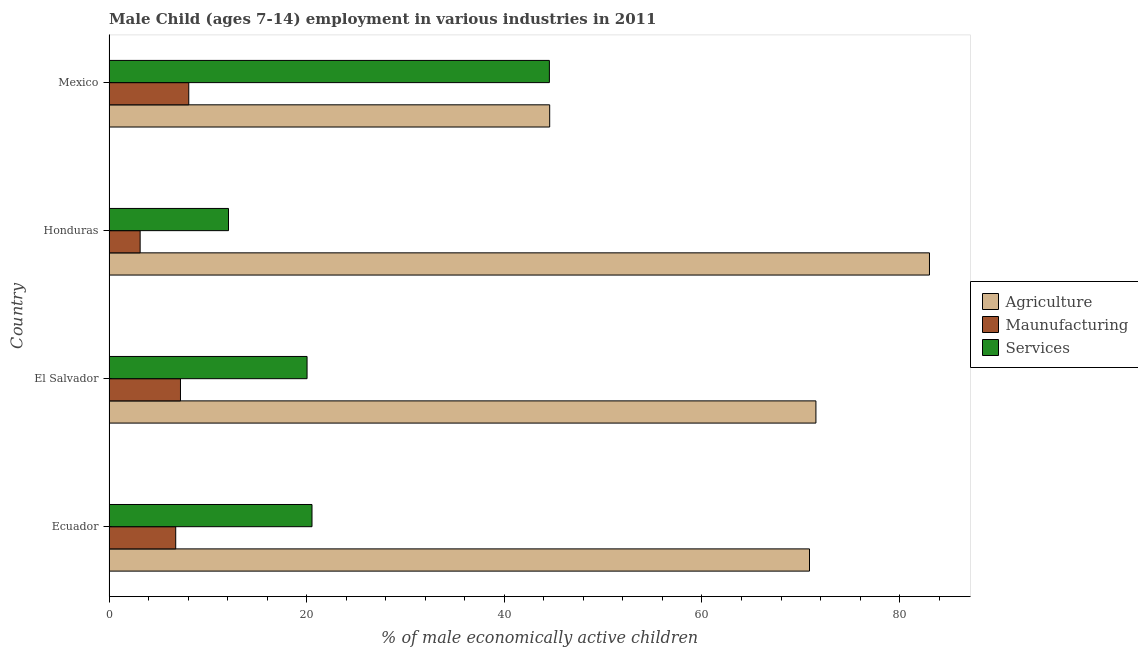How many different coloured bars are there?
Your answer should be very brief. 3. Are the number of bars on each tick of the Y-axis equal?
Provide a succinct answer. Yes. In how many cases, is the number of bars for a given country not equal to the number of legend labels?
Provide a succinct answer. 0. What is the percentage of economically active children in services in Ecuador?
Your answer should be very brief. 20.54. Across all countries, what is the maximum percentage of economically active children in manufacturing?
Give a very brief answer. 8.07. Across all countries, what is the minimum percentage of economically active children in services?
Give a very brief answer. 12.09. In which country was the percentage of economically active children in services maximum?
Your answer should be very brief. Mexico. What is the total percentage of economically active children in agriculture in the graph?
Keep it short and to the point. 270.02. What is the difference between the percentage of economically active children in agriculture in Ecuador and that in Mexico?
Ensure brevity in your answer.  26.29. What is the difference between the percentage of economically active children in agriculture in Honduras and the percentage of economically active children in manufacturing in Mexico?
Offer a very short reply. 74.95. What is the average percentage of economically active children in services per country?
Offer a very short reply. 24.31. What is the difference between the percentage of economically active children in agriculture and percentage of economically active children in manufacturing in Honduras?
Give a very brief answer. 79.87. What is the ratio of the percentage of economically active children in agriculture in Honduras to that in Mexico?
Your answer should be compact. 1.86. Is the percentage of economically active children in manufacturing in Ecuador less than that in El Salvador?
Make the answer very short. Yes. Is the difference between the percentage of economically active children in agriculture in Honduras and Mexico greater than the difference between the percentage of economically active children in services in Honduras and Mexico?
Your answer should be compact. Yes. What is the difference between the highest and the second highest percentage of economically active children in services?
Your answer should be compact. 24.02. What is the difference between the highest and the lowest percentage of economically active children in services?
Offer a terse response. 32.47. In how many countries, is the percentage of economically active children in manufacturing greater than the average percentage of economically active children in manufacturing taken over all countries?
Give a very brief answer. 3. What does the 3rd bar from the top in Mexico represents?
Your response must be concise. Agriculture. What does the 1st bar from the bottom in Mexico represents?
Give a very brief answer. Agriculture. Are all the bars in the graph horizontal?
Your answer should be very brief. Yes. How many countries are there in the graph?
Keep it short and to the point. 4. What is the difference between two consecutive major ticks on the X-axis?
Ensure brevity in your answer.  20. Are the values on the major ticks of X-axis written in scientific E-notation?
Offer a terse response. No. Does the graph contain any zero values?
Your answer should be compact. No. Where does the legend appear in the graph?
Offer a terse response. Center right. How many legend labels are there?
Your answer should be very brief. 3. How are the legend labels stacked?
Offer a very short reply. Vertical. What is the title of the graph?
Make the answer very short. Male Child (ages 7-14) employment in various industries in 2011. Does "Nuclear sources" appear as one of the legend labels in the graph?
Give a very brief answer. No. What is the label or title of the X-axis?
Give a very brief answer. % of male economically active children. What is the label or title of the Y-axis?
Offer a very short reply. Country. What is the % of male economically active children in Agriculture in Ecuador?
Offer a very short reply. 70.88. What is the % of male economically active children of Maunufacturing in Ecuador?
Offer a terse response. 6.75. What is the % of male economically active children in Services in Ecuador?
Make the answer very short. 20.54. What is the % of male economically active children of Agriculture in El Salvador?
Your answer should be very brief. 71.53. What is the % of male economically active children in Maunufacturing in El Salvador?
Your answer should be very brief. 7.23. What is the % of male economically active children in Services in El Salvador?
Offer a very short reply. 20.04. What is the % of male economically active children of Agriculture in Honduras?
Provide a short and direct response. 83.02. What is the % of male economically active children of Maunufacturing in Honduras?
Give a very brief answer. 3.15. What is the % of male economically active children in Services in Honduras?
Keep it short and to the point. 12.09. What is the % of male economically active children in Agriculture in Mexico?
Offer a terse response. 44.59. What is the % of male economically active children in Maunufacturing in Mexico?
Give a very brief answer. 8.07. What is the % of male economically active children in Services in Mexico?
Offer a very short reply. 44.56. Across all countries, what is the maximum % of male economically active children of Agriculture?
Provide a succinct answer. 83.02. Across all countries, what is the maximum % of male economically active children in Maunufacturing?
Ensure brevity in your answer.  8.07. Across all countries, what is the maximum % of male economically active children of Services?
Offer a very short reply. 44.56. Across all countries, what is the minimum % of male economically active children of Agriculture?
Offer a terse response. 44.59. Across all countries, what is the minimum % of male economically active children in Maunufacturing?
Provide a succinct answer. 3.15. Across all countries, what is the minimum % of male economically active children of Services?
Give a very brief answer. 12.09. What is the total % of male economically active children in Agriculture in the graph?
Your response must be concise. 270.02. What is the total % of male economically active children of Maunufacturing in the graph?
Keep it short and to the point. 25.2. What is the total % of male economically active children in Services in the graph?
Your response must be concise. 97.23. What is the difference between the % of male economically active children of Agriculture in Ecuador and that in El Salvador?
Ensure brevity in your answer.  -0.65. What is the difference between the % of male economically active children of Maunufacturing in Ecuador and that in El Salvador?
Give a very brief answer. -0.48. What is the difference between the % of male economically active children in Agriculture in Ecuador and that in Honduras?
Your answer should be compact. -12.14. What is the difference between the % of male economically active children in Services in Ecuador and that in Honduras?
Provide a succinct answer. 8.45. What is the difference between the % of male economically active children in Agriculture in Ecuador and that in Mexico?
Ensure brevity in your answer.  26.29. What is the difference between the % of male economically active children of Maunufacturing in Ecuador and that in Mexico?
Your answer should be compact. -1.32. What is the difference between the % of male economically active children in Services in Ecuador and that in Mexico?
Give a very brief answer. -24.02. What is the difference between the % of male economically active children in Agriculture in El Salvador and that in Honduras?
Offer a very short reply. -11.49. What is the difference between the % of male economically active children in Maunufacturing in El Salvador and that in Honduras?
Offer a terse response. 4.08. What is the difference between the % of male economically active children of Services in El Salvador and that in Honduras?
Your answer should be compact. 7.95. What is the difference between the % of male economically active children of Agriculture in El Salvador and that in Mexico?
Keep it short and to the point. 26.94. What is the difference between the % of male economically active children of Maunufacturing in El Salvador and that in Mexico?
Ensure brevity in your answer.  -0.84. What is the difference between the % of male economically active children of Services in El Salvador and that in Mexico?
Your answer should be compact. -24.52. What is the difference between the % of male economically active children of Agriculture in Honduras and that in Mexico?
Provide a short and direct response. 38.43. What is the difference between the % of male economically active children of Maunufacturing in Honduras and that in Mexico?
Your response must be concise. -4.92. What is the difference between the % of male economically active children in Services in Honduras and that in Mexico?
Provide a succinct answer. -32.47. What is the difference between the % of male economically active children in Agriculture in Ecuador and the % of male economically active children in Maunufacturing in El Salvador?
Your answer should be very brief. 63.65. What is the difference between the % of male economically active children in Agriculture in Ecuador and the % of male economically active children in Services in El Salvador?
Give a very brief answer. 50.84. What is the difference between the % of male economically active children in Maunufacturing in Ecuador and the % of male economically active children in Services in El Salvador?
Offer a terse response. -13.29. What is the difference between the % of male economically active children in Agriculture in Ecuador and the % of male economically active children in Maunufacturing in Honduras?
Give a very brief answer. 67.73. What is the difference between the % of male economically active children of Agriculture in Ecuador and the % of male economically active children of Services in Honduras?
Make the answer very short. 58.79. What is the difference between the % of male economically active children in Maunufacturing in Ecuador and the % of male economically active children in Services in Honduras?
Make the answer very short. -5.34. What is the difference between the % of male economically active children of Agriculture in Ecuador and the % of male economically active children of Maunufacturing in Mexico?
Give a very brief answer. 62.81. What is the difference between the % of male economically active children in Agriculture in Ecuador and the % of male economically active children in Services in Mexico?
Give a very brief answer. 26.32. What is the difference between the % of male economically active children of Maunufacturing in Ecuador and the % of male economically active children of Services in Mexico?
Your answer should be compact. -37.81. What is the difference between the % of male economically active children in Agriculture in El Salvador and the % of male economically active children in Maunufacturing in Honduras?
Offer a terse response. 68.38. What is the difference between the % of male economically active children in Agriculture in El Salvador and the % of male economically active children in Services in Honduras?
Your answer should be very brief. 59.44. What is the difference between the % of male economically active children in Maunufacturing in El Salvador and the % of male economically active children in Services in Honduras?
Offer a very short reply. -4.86. What is the difference between the % of male economically active children in Agriculture in El Salvador and the % of male economically active children in Maunufacturing in Mexico?
Your answer should be very brief. 63.46. What is the difference between the % of male economically active children in Agriculture in El Salvador and the % of male economically active children in Services in Mexico?
Keep it short and to the point. 26.97. What is the difference between the % of male economically active children of Maunufacturing in El Salvador and the % of male economically active children of Services in Mexico?
Your response must be concise. -37.33. What is the difference between the % of male economically active children in Agriculture in Honduras and the % of male economically active children in Maunufacturing in Mexico?
Make the answer very short. 74.95. What is the difference between the % of male economically active children in Agriculture in Honduras and the % of male economically active children in Services in Mexico?
Provide a short and direct response. 38.46. What is the difference between the % of male economically active children in Maunufacturing in Honduras and the % of male economically active children in Services in Mexico?
Provide a short and direct response. -41.41. What is the average % of male economically active children of Agriculture per country?
Your response must be concise. 67.5. What is the average % of male economically active children in Services per country?
Give a very brief answer. 24.31. What is the difference between the % of male economically active children of Agriculture and % of male economically active children of Maunufacturing in Ecuador?
Offer a very short reply. 64.13. What is the difference between the % of male economically active children of Agriculture and % of male economically active children of Services in Ecuador?
Ensure brevity in your answer.  50.34. What is the difference between the % of male economically active children in Maunufacturing and % of male economically active children in Services in Ecuador?
Your answer should be compact. -13.79. What is the difference between the % of male economically active children in Agriculture and % of male economically active children in Maunufacturing in El Salvador?
Keep it short and to the point. 64.3. What is the difference between the % of male economically active children of Agriculture and % of male economically active children of Services in El Salvador?
Offer a very short reply. 51.49. What is the difference between the % of male economically active children of Maunufacturing and % of male economically active children of Services in El Salvador?
Make the answer very short. -12.81. What is the difference between the % of male economically active children of Agriculture and % of male economically active children of Maunufacturing in Honduras?
Make the answer very short. 79.87. What is the difference between the % of male economically active children of Agriculture and % of male economically active children of Services in Honduras?
Offer a very short reply. 70.93. What is the difference between the % of male economically active children of Maunufacturing and % of male economically active children of Services in Honduras?
Make the answer very short. -8.94. What is the difference between the % of male economically active children of Agriculture and % of male economically active children of Maunufacturing in Mexico?
Offer a very short reply. 36.52. What is the difference between the % of male economically active children of Agriculture and % of male economically active children of Services in Mexico?
Offer a terse response. 0.03. What is the difference between the % of male economically active children in Maunufacturing and % of male economically active children in Services in Mexico?
Your answer should be compact. -36.49. What is the ratio of the % of male economically active children in Agriculture in Ecuador to that in El Salvador?
Provide a short and direct response. 0.99. What is the ratio of the % of male economically active children of Maunufacturing in Ecuador to that in El Salvador?
Your answer should be very brief. 0.93. What is the ratio of the % of male economically active children of Agriculture in Ecuador to that in Honduras?
Provide a succinct answer. 0.85. What is the ratio of the % of male economically active children of Maunufacturing in Ecuador to that in Honduras?
Ensure brevity in your answer.  2.14. What is the ratio of the % of male economically active children in Services in Ecuador to that in Honduras?
Your answer should be very brief. 1.7. What is the ratio of the % of male economically active children in Agriculture in Ecuador to that in Mexico?
Your answer should be very brief. 1.59. What is the ratio of the % of male economically active children of Maunufacturing in Ecuador to that in Mexico?
Your answer should be compact. 0.84. What is the ratio of the % of male economically active children of Services in Ecuador to that in Mexico?
Your answer should be compact. 0.46. What is the ratio of the % of male economically active children in Agriculture in El Salvador to that in Honduras?
Offer a very short reply. 0.86. What is the ratio of the % of male economically active children in Maunufacturing in El Salvador to that in Honduras?
Offer a terse response. 2.3. What is the ratio of the % of male economically active children in Services in El Salvador to that in Honduras?
Offer a terse response. 1.66. What is the ratio of the % of male economically active children of Agriculture in El Salvador to that in Mexico?
Offer a very short reply. 1.6. What is the ratio of the % of male economically active children in Maunufacturing in El Salvador to that in Mexico?
Your response must be concise. 0.9. What is the ratio of the % of male economically active children in Services in El Salvador to that in Mexico?
Ensure brevity in your answer.  0.45. What is the ratio of the % of male economically active children of Agriculture in Honduras to that in Mexico?
Keep it short and to the point. 1.86. What is the ratio of the % of male economically active children of Maunufacturing in Honduras to that in Mexico?
Your answer should be very brief. 0.39. What is the ratio of the % of male economically active children of Services in Honduras to that in Mexico?
Your response must be concise. 0.27. What is the difference between the highest and the second highest % of male economically active children in Agriculture?
Make the answer very short. 11.49. What is the difference between the highest and the second highest % of male economically active children in Maunufacturing?
Offer a very short reply. 0.84. What is the difference between the highest and the second highest % of male economically active children in Services?
Offer a terse response. 24.02. What is the difference between the highest and the lowest % of male economically active children of Agriculture?
Your response must be concise. 38.43. What is the difference between the highest and the lowest % of male economically active children of Maunufacturing?
Your answer should be compact. 4.92. What is the difference between the highest and the lowest % of male economically active children in Services?
Make the answer very short. 32.47. 